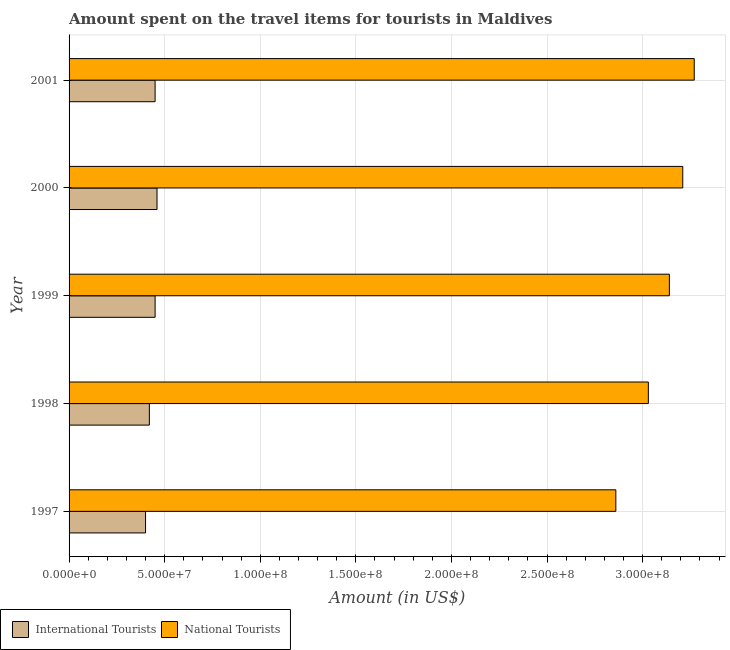How many different coloured bars are there?
Give a very brief answer. 2. How many bars are there on the 3rd tick from the top?
Keep it short and to the point. 2. How many bars are there on the 5th tick from the bottom?
Offer a very short reply. 2. What is the label of the 3rd group of bars from the top?
Provide a succinct answer. 1999. In how many cases, is the number of bars for a given year not equal to the number of legend labels?
Your answer should be compact. 0. What is the amount spent on travel items of international tourists in 1998?
Provide a short and direct response. 4.20e+07. Across all years, what is the maximum amount spent on travel items of national tourists?
Your answer should be compact. 3.27e+08. Across all years, what is the minimum amount spent on travel items of international tourists?
Offer a terse response. 4.00e+07. What is the total amount spent on travel items of international tourists in the graph?
Provide a short and direct response. 2.18e+08. What is the difference between the amount spent on travel items of national tourists in 1999 and that in 2000?
Offer a terse response. -7.00e+06. What is the difference between the amount spent on travel items of national tourists in 1999 and the amount spent on travel items of international tourists in 2001?
Make the answer very short. 2.69e+08. What is the average amount spent on travel items of national tourists per year?
Your answer should be compact. 3.10e+08. In the year 2000, what is the difference between the amount spent on travel items of national tourists and amount spent on travel items of international tourists?
Make the answer very short. 2.75e+08. Is the amount spent on travel items of national tourists in 1998 less than that in 2001?
Your answer should be very brief. Yes. What is the difference between the highest and the lowest amount spent on travel items of international tourists?
Give a very brief answer. 6.00e+06. In how many years, is the amount spent on travel items of international tourists greater than the average amount spent on travel items of international tourists taken over all years?
Keep it short and to the point. 3. What does the 1st bar from the top in 2000 represents?
Offer a terse response. National Tourists. What does the 1st bar from the bottom in 2001 represents?
Offer a terse response. International Tourists. How many bars are there?
Give a very brief answer. 10. How many years are there in the graph?
Make the answer very short. 5. What is the difference between two consecutive major ticks on the X-axis?
Keep it short and to the point. 5.00e+07. Does the graph contain any zero values?
Your answer should be compact. No. Where does the legend appear in the graph?
Your response must be concise. Bottom left. How are the legend labels stacked?
Ensure brevity in your answer.  Horizontal. What is the title of the graph?
Make the answer very short. Amount spent on the travel items for tourists in Maldives. What is the label or title of the Y-axis?
Offer a very short reply. Year. What is the Amount (in US$) in International Tourists in 1997?
Make the answer very short. 4.00e+07. What is the Amount (in US$) in National Tourists in 1997?
Your answer should be compact. 2.86e+08. What is the Amount (in US$) of International Tourists in 1998?
Make the answer very short. 4.20e+07. What is the Amount (in US$) in National Tourists in 1998?
Provide a succinct answer. 3.03e+08. What is the Amount (in US$) of International Tourists in 1999?
Keep it short and to the point. 4.50e+07. What is the Amount (in US$) of National Tourists in 1999?
Keep it short and to the point. 3.14e+08. What is the Amount (in US$) in International Tourists in 2000?
Provide a short and direct response. 4.60e+07. What is the Amount (in US$) in National Tourists in 2000?
Make the answer very short. 3.21e+08. What is the Amount (in US$) of International Tourists in 2001?
Offer a very short reply. 4.50e+07. What is the Amount (in US$) in National Tourists in 2001?
Your answer should be compact. 3.27e+08. Across all years, what is the maximum Amount (in US$) of International Tourists?
Your answer should be very brief. 4.60e+07. Across all years, what is the maximum Amount (in US$) of National Tourists?
Ensure brevity in your answer.  3.27e+08. Across all years, what is the minimum Amount (in US$) in International Tourists?
Provide a short and direct response. 4.00e+07. Across all years, what is the minimum Amount (in US$) in National Tourists?
Offer a very short reply. 2.86e+08. What is the total Amount (in US$) of International Tourists in the graph?
Your response must be concise. 2.18e+08. What is the total Amount (in US$) of National Tourists in the graph?
Provide a short and direct response. 1.55e+09. What is the difference between the Amount (in US$) of International Tourists in 1997 and that in 1998?
Your response must be concise. -2.00e+06. What is the difference between the Amount (in US$) of National Tourists in 1997 and that in 1998?
Offer a very short reply. -1.70e+07. What is the difference between the Amount (in US$) of International Tourists in 1997 and that in 1999?
Give a very brief answer. -5.00e+06. What is the difference between the Amount (in US$) in National Tourists in 1997 and that in 1999?
Offer a terse response. -2.80e+07. What is the difference between the Amount (in US$) in International Tourists in 1997 and that in 2000?
Ensure brevity in your answer.  -6.00e+06. What is the difference between the Amount (in US$) of National Tourists in 1997 and that in 2000?
Offer a very short reply. -3.50e+07. What is the difference between the Amount (in US$) in International Tourists in 1997 and that in 2001?
Make the answer very short. -5.00e+06. What is the difference between the Amount (in US$) in National Tourists in 1997 and that in 2001?
Offer a very short reply. -4.10e+07. What is the difference between the Amount (in US$) in National Tourists in 1998 and that in 1999?
Offer a very short reply. -1.10e+07. What is the difference between the Amount (in US$) in International Tourists in 1998 and that in 2000?
Provide a succinct answer. -4.00e+06. What is the difference between the Amount (in US$) of National Tourists in 1998 and that in 2000?
Keep it short and to the point. -1.80e+07. What is the difference between the Amount (in US$) of National Tourists in 1998 and that in 2001?
Your answer should be compact. -2.40e+07. What is the difference between the Amount (in US$) of International Tourists in 1999 and that in 2000?
Ensure brevity in your answer.  -1.00e+06. What is the difference between the Amount (in US$) of National Tourists in 1999 and that in 2000?
Your response must be concise. -7.00e+06. What is the difference between the Amount (in US$) of International Tourists in 1999 and that in 2001?
Give a very brief answer. 0. What is the difference between the Amount (in US$) in National Tourists in 1999 and that in 2001?
Offer a terse response. -1.30e+07. What is the difference between the Amount (in US$) in International Tourists in 2000 and that in 2001?
Offer a very short reply. 1.00e+06. What is the difference between the Amount (in US$) of National Tourists in 2000 and that in 2001?
Provide a succinct answer. -6.00e+06. What is the difference between the Amount (in US$) in International Tourists in 1997 and the Amount (in US$) in National Tourists in 1998?
Offer a very short reply. -2.63e+08. What is the difference between the Amount (in US$) of International Tourists in 1997 and the Amount (in US$) of National Tourists in 1999?
Offer a terse response. -2.74e+08. What is the difference between the Amount (in US$) of International Tourists in 1997 and the Amount (in US$) of National Tourists in 2000?
Your answer should be very brief. -2.81e+08. What is the difference between the Amount (in US$) of International Tourists in 1997 and the Amount (in US$) of National Tourists in 2001?
Offer a very short reply. -2.87e+08. What is the difference between the Amount (in US$) in International Tourists in 1998 and the Amount (in US$) in National Tourists in 1999?
Make the answer very short. -2.72e+08. What is the difference between the Amount (in US$) of International Tourists in 1998 and the Amount (in US$) of National Tourists in 2000?
Give a very brief answer. -2.79e+08. What is the difference between the Amount (in US$) of International Tourists in 1998 and the Amount (in US$) of National Tourists in 2001?
Offer a very short reply. -2.85e+08. What is the difference between the Amount (in US$) in International Tourists in 1999 and the Amount (in US$) in National Tourists in 2000?
Make the answer very short. -2.76e+08. What is the difference between the Amount (in US$) in International Tourists in 1999 and the Amount (in US$) in National Tourists in 2001?
Make the answer very short. -2.82e+08. What is the difference between the Amount (in US$) of International Tourists in 2000 and the Amount (in US$) of National Tourists in 2001?
Ensure brevity in your answer.  -2.81e+08. What is the average Amount (in US$) of International Tourists per year?
Ensure brevity in your answer.  4.36e+07. What is the average Amount (in US$) in National Tourists per year?
Ensure brevity in your answer.  3.10e+08. In the year 1997, what is the difference between the Amount (in US$) in International Tourists and Amount (in US$) in National Tourists?
Provide a short and direct response. -2.46e+08. In the year 1998, what is the difference between the Amount (in US$) in International Tourists and Amount (in US$) in National Tourists?
Give a very brief answer. -2.61e+08. In the year 1999, what is the difference between the Amount (in US$) of International Tourists and Amount (in US$) of National Tourists?
Offer a very short reply. -2.69e+08. In the year 2000, what is the difference between the Amount (in US$) of International Tourists and Amount (in US$) of National Tourists?
Provide a succinct answer. -2.75e+08. In the year 2001, what is the difference between the Amount (in US$) in International Tourists and Amount (in US$) in National Tourists?
Provide a succinct answer. -2.82e+08. What is the ratio of the Amount (in US$) of International Tourists in 1997 to that in 1998?
Your response must be concise. 0.95. What is the ratio of the Amount (in US$) in National Tourists in 1997 to that in 1998?
Your answer should be very brief. 0.94. What is the ratio of the Amount (in US$) in National Tourists in 1997 to that in 1999?
Your answer should be compact. 0.91. What is the ratio of the Amount (in US$) of International Tourists in 1997 to that in 2000?
Give a very brief answer. 0.87. What is the ratio of the Amount (in US$) of National Tourists in 1997 to that in 2000?
Your answer should be compact. 0.89. What is the ratio of the Amount (in US$) in National Tourists in 1997 to that in 2001?
Provide a short and direct response. 0.87. What is the ratio of the Amount (in US$) in National Tourists in 1998 to that in 2000?
Make the answer very short. 0.94. What is the ratio of the Amount (in US$) in National Tourists in 1998 to that in 2001?
Make the answer very short. 0.93. What is the ratio of the Amount (in US$) in International Tourists in 1999 to that in 2000?
Your answer should be compact. 0.98. What is the ratio of the Amount (in US$) of National Tourists in 1999 to that in 2000?
Offer a very short reply. 0.98. What is the ratio of the Amount (in US$) in National Tourists in 1999 to that in 2001?
Provide a succinct answer. 0.96. What is the ratio of the Amount (in US$) in International Tourists in 2000 to that in 2001?
Provide a succinct answer. 1.02. What is the ratio of the Amount (in US$) of National Tourists in 2000 to that in 2001?
Ensure brevity in your answer.  0.98. What is the difference between the highest and the second highest Amount (in US$) of National Tourists?
Offer a terse response. 6.00e+06. What is the difference between the highest and the lowest Amount (in US$) in International Tourists?
Ensure brevity in your answer.  6.00e+06. What is the difference between the highest and the lowest Amount (in US$) of National Tourists?
Your answer should be very brief. 4.10e+07. 